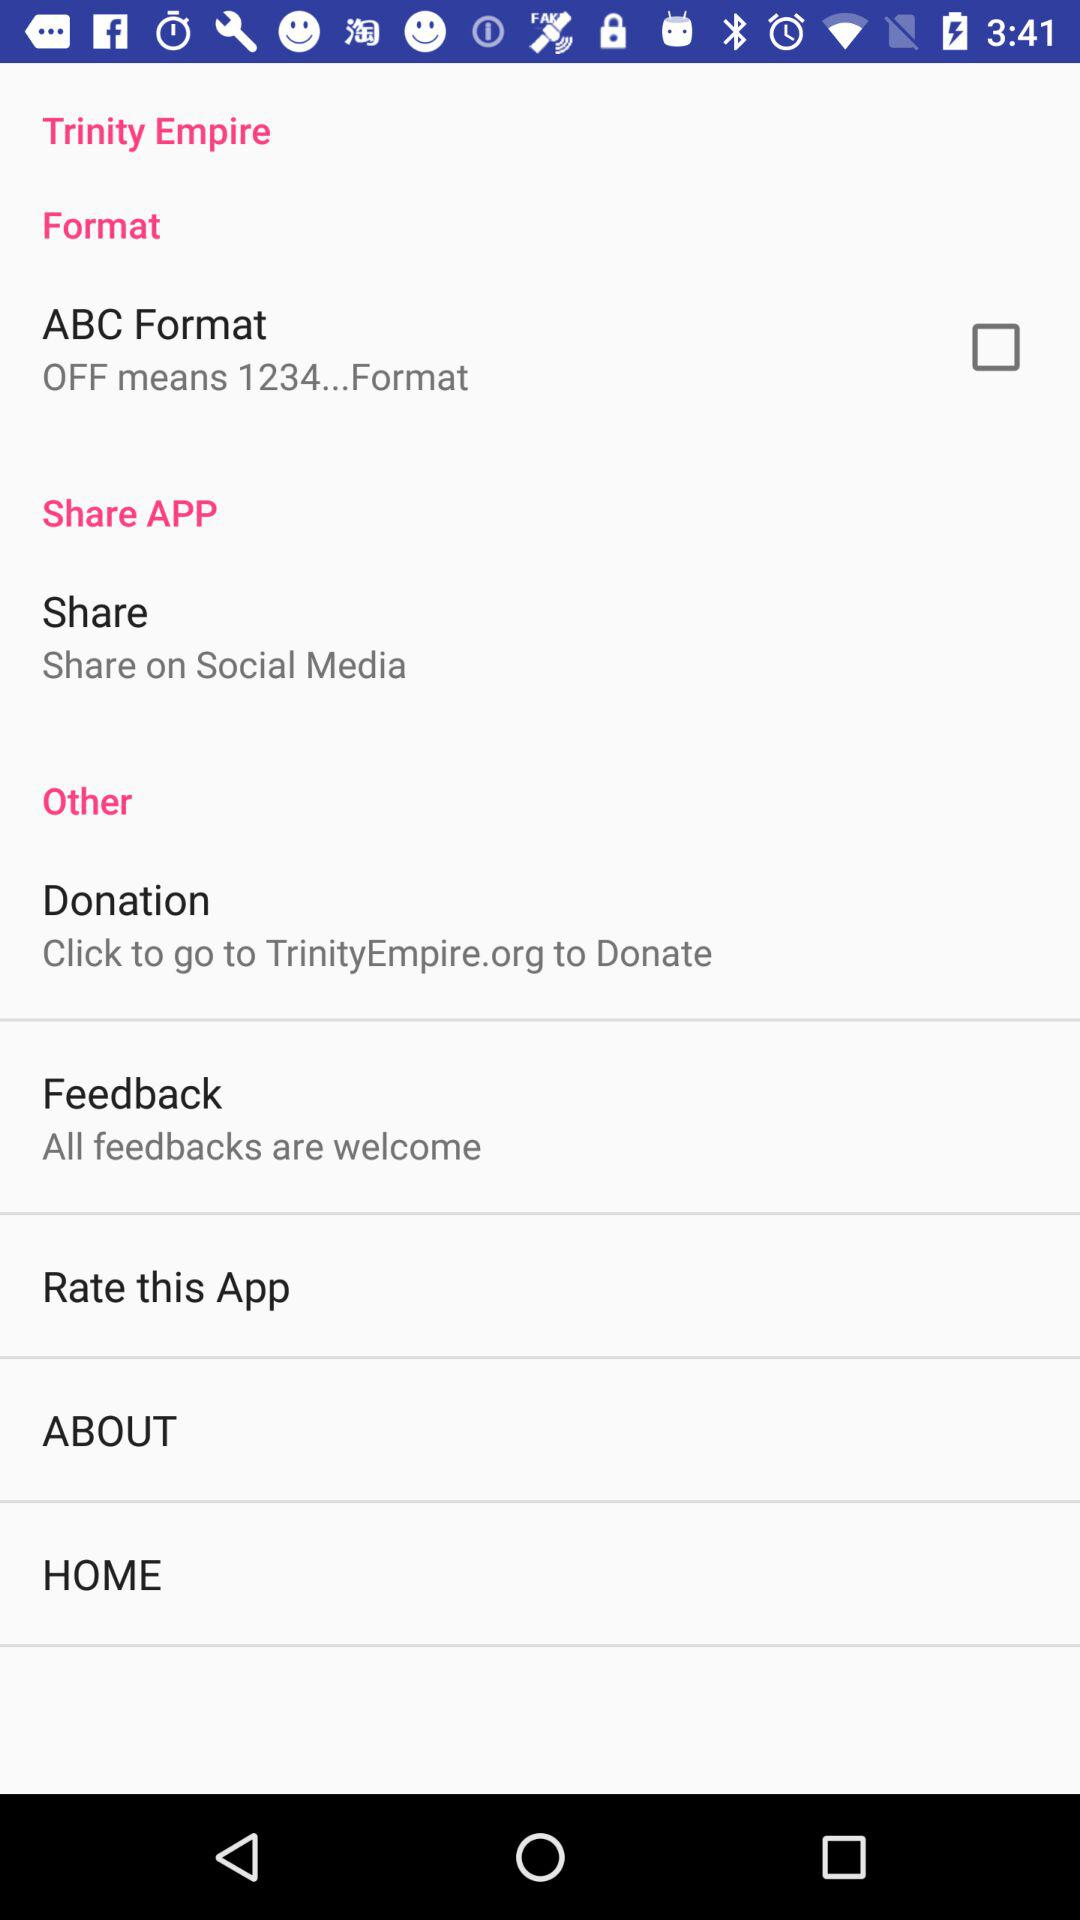Is "ABC Format" checked or unchecked? "ABC Format" is unchecked. 